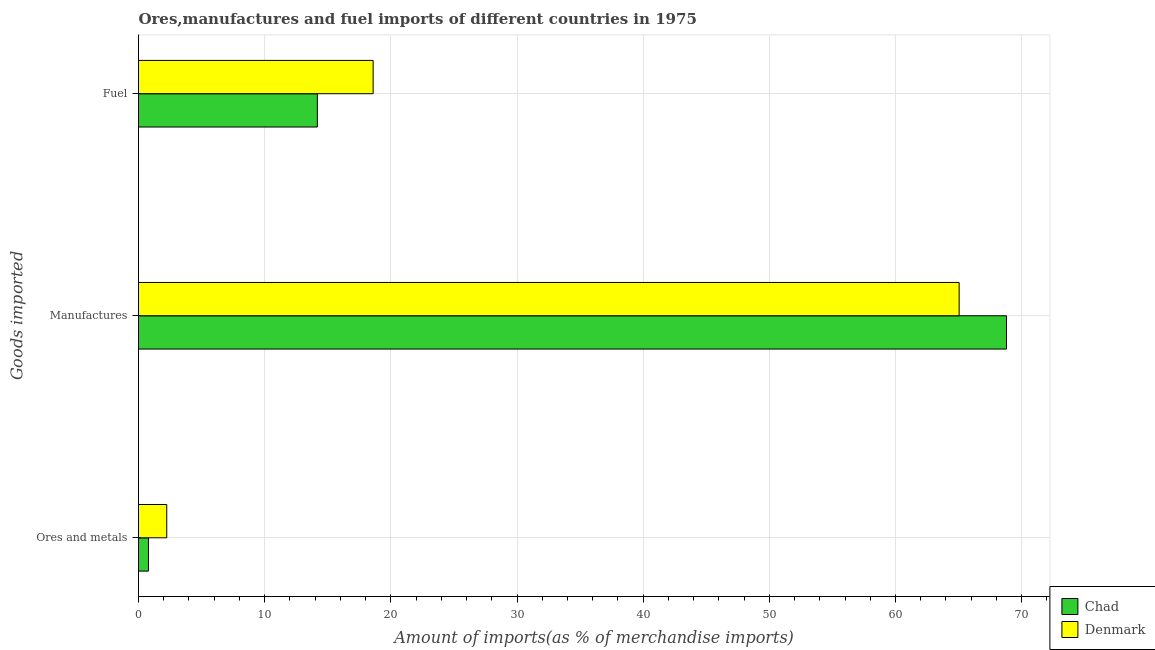How many different coloured bars are there?
Provide a succinct answer. 2. Are the number of bars per tick equal to the number of legend labels?
Make the answer very short. Yes. How many bars are there on the 2nd tick from the bottom?
Your answer should be compact. 2. What is the label of the 2nd group of bars from the top?
Offer a terse response. Manufactures. What is the percentage of manufactures imports in Chad?
Offer a very short reply. 68.8. Across all countries, what is the maximum percentage of ores and metals imports?
Offer a very short reply. 2.24. Across all countries, what is the minimum percentage of ores and metals imports?
Your answer should be very brief. 0.79. In which country was the percentage of ores and metals imports minimum?
Provide a short and direct response. Chad. What is the total percentage of fuel imports in the graph?
Keep it short and to the point. 32.77. What is the difference between the percentage of ores and metals imports in Denmark and that in Chad?
Provide a succinct answer. 1.45. What is the difference between the percentage of ores and metals imports in Chad and the percentage of fuel imports in Denmark?
Your answer should be compact. -17.81. What is the average percentage of ores and metals imports per country?
Offer a very short reply. 1.51. What is the difference between the percentage of fuel imports and percentage of manufactures imports in Chad?
Offer a very short reply. -54.62. In how many countries, is the percentage of ores and metals imports greater than 58 %?
Your response must be concise. 0. What is the ratio of the percentage of manufactures imports in Chad to that in Denmark?
Your answer should be very brief. 1.06. Is the difference between the percentage of manufactures imports in Denmark and Chad greater than the difference between the percentage of fuel imports in Denmark and Chad?
Provide a short and direct response. No. What is the difference between the highest and the second highest percentage of fuel imports?
Keep it short and to the point. 4.42. What is the difference between the highest and the lowest percentage of fuel imports?
Your answer should be very brief. 4.42. In how many countries, is the percentage of manufactures imports greater than the average percentage of manufactures imports taken over all countries?
Offer a very short reply. 1. Is the sum of the percentage of manufactures imports in Chad and Denmark greater than the maximum percentage of fuel imports across all countries?
Offer a very short reply. Yes. What does the 2nd bar from the top in Manufactures represents?
Your answer should be compact. Chad. Is it the case that in every country, the sum of the percentage of ores and metals imports and percentage of manufactures imports is greater than the percentage of fuel imports?
Provide a short and direct response. Yes. Are the values on the major ticks of X-axis written in scientific E-notation?
Provide a succinct answer. No. Does the graph contain grids?
Provide a short and direct response. Yes. Where does the legend appear in the graph?
Provide a succinct answer. Bottom right. How are the legend labels stacked?
Your answer should be very brief. Vertical. What is the title of the graph?
Offer a very short reply. Ores,manufactures and fuel imports of different countries in 1975. What is the label or title of the X-axis?
Your response must be concise. Amount of imports(as % of merchandise imports). What is the label or title of the Y-axis?
Offer a very short reply. Goods imported. What is the Amount of imports(as % of merchandise imports) of Chad in Ores and metals?
Ensure brevity in your answer.  0.79. What is the Amount of imports(as % of merchandise imports) of Denmark in Ores and metals?
Your answer should be very brief. 2.24. What is the Amount of imports(as % of merchandise imports) of Chad in Manufactures?
Your answer should be compact. 68.8. What is the Amount of imports(as % of merchandise imports) of Denmark in Manufactures?
Give a very brief answer. 65.05. What is the Amount of imports(as % of merchandise imports) in Chad in Fuel?
Give a very brief answer. 14.17. What is the Amount of imports(as % of merchandise imports) in Denmark in Fuel?
Your response must be concise. 18.6. Across all Goods imported, what is the maximum Amount of imports(as % of merchandise imports) in Chad?
Your response must be concise. 68.8. Across all Goods imported, what is the maximum Amount of imports(as % of merchandise imports) of Denmark?
Keep it short and to the point. 65.05. Across all Goods imported, what is the minimum Amount of imports(as % of merchandise imports) of Chad?
Ensure brevity in your answer.  0.79. Across all Goods imported, what is the minimum Amount of imports(as % of merchandise imports) of Denmark?
Keep it short and to the point. 2.24. What is the total Amount of imports(as % of merchandise imports) of Chad in the graph?
Your answer should be very brief. 83.76. What is the total Amount of imports(as % of merchandise imports) of Denmark in the graph?
Keep it short and to the point. 85.88. What is the difference between the Amount of imports(as % of merchandise imports) of Chad in Ores and metals and that in Manufactures?
Your response must be concise. -68.01. What is the difference between the Amount of imports(as % of merchandise imports) in Denmark in Ores and metals and that in Manufactures?
Provide a short and direct response. -62.81. What is the difference between the Amount of imports(as % of merchandise imports) of Chad in Ores and metals and that in Fuel?
Ensure brevity in your answer.  -13.38. What is the difference between the Amount of imports(as % of merchandise imports) of Denmark in Ores and metals and that in Fuel?
Keep it short and to the point. -16.36. What is the difference between the Amount of imports(as % of merchandise imports) of Chad in Manufactures and that in Fuel?
Provide a short and direct response. 54.62. What is the difference between the Amount of imports(as % of merchandise imports) in Denmark in Manufactures and that in Fuel?
Your answer should be very brief. 46.45. What is the difference between the Amount of imports(as % of merchandise imports) in Chad in Ores and metals and the Amount of imports(as % of merchandise imports) in Denmark in Manufactures?
Ensure brevity in your answer.  -64.26. What is the difference between the Amount of imports(as % of merchandise imports) in Chad in Ores and metals and the Amount of imports(as % of merchandise imports) in Denmark in Fuel?
Offer a very short reply. -17.81. What is the difference between the Amount of imports(as % of merchandise imports) in Chad in Manufactures and the Amount of imports(as % of merchandise imports) in Denmark in Fuel?
Provide a succinct answer. 50.2. What is the average Amount of imports(as % of merchandise imports) in Chad per Goods imported?
Offer a very short reply. 27.92. What is the average Amount of imports(as % of merchandise imports) in Denmark per Goods imported?
Offer a very short reply. 28.63. What is the difference between the Amount of imports(as % of merchandise imports) in Chad and Amount of imports(as % of merchandise imports) in Denmark in Ores and metals?
Offer a very short reply. -1.45. What is the difference between the Amount of imports(as % of merchandise imports) in Chad and Amount of imports(as % of merchandise imports) in Denmark in Manufactures?
Provide a succinct answer. 3.75. What is the difference between the Amount of imports(as % of merchandise imports) in Chad and Amount of imports(as % of merchandise imports) in Denmark in Fuel?
Offer a very short reply. -4.42. What is the ratio of the Amount of imports(as % of merchandise imports) of Chad in Ores and metals to that in Manufactures?
Your answer should be compact. 0.01. What is the ratio of the Amount of imports(as % of merchandise imports) in Denmark in Ores and metals to that in Manufactures?
Give a very brief answer. 0.03. What is the ratio of the Amount of imports(as % of merchandise imports) in Chad in Ores and metals to that in Fuel?
Make the answer very short. 0.06. What is the ratio of the Amount of imports(as % of merchandise imports) of Denmark in Ores and metals to that in Fuel?
Your answer should be very brief. 0.12. What is the ratio of the Amount of imports(as % of merchandise imports) of Chad in Manufactures to that in Fuel?
Offer a very short reply. 4.85. What is the ratio of the Amount of imports(as % of merchandise imports) in Denmark in Manufactures to that in Fuel?
Your response must be concise. 3.5. What is the difference between the highest and the second highest Amount of imports(as % of merchandise imports) of Chad?
Offer a very short reply. 54.62. What is the difference between the highest and the second highest Amount of imports(as % of merchandise imports) of Denmark?
Offer a very short reply. 46.45. What is the difference between the highest and the lowest Amount of imports(as % of merchandise imports) in Chad?
Your answer should be very brief. 68.01. What is the difference between the highest and the lowest Amount of imports(as % of merchandise imports) of Denmark?
Your answer should be compact. 62.81. 